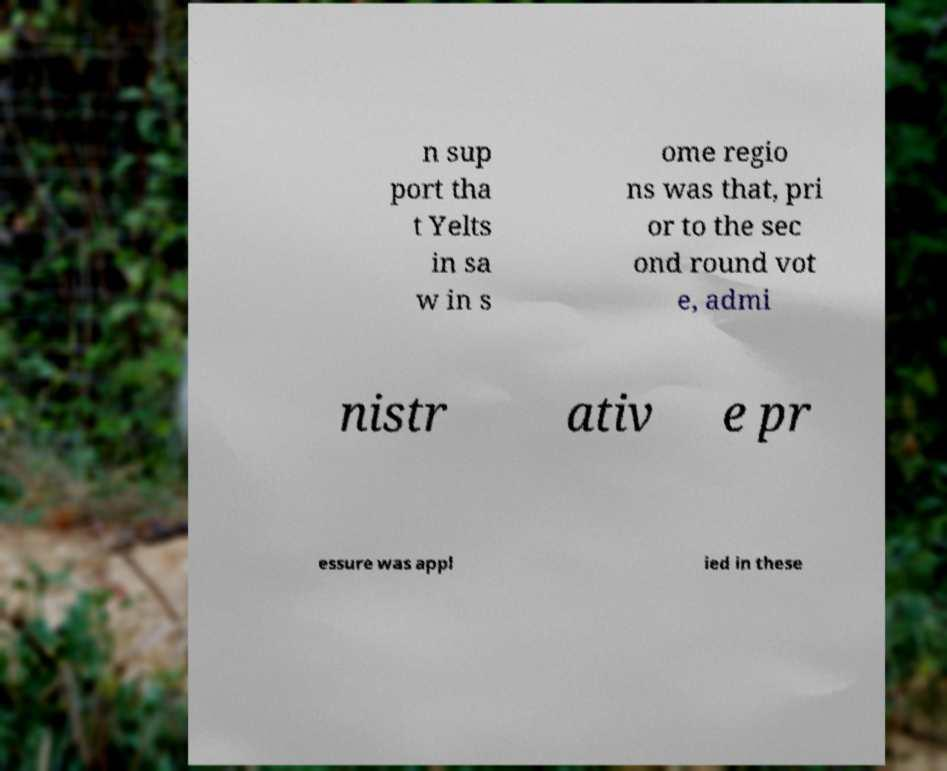There's text embedded in this image that I need extracted. Can you transcribe it verbatim? n sup port tha t Yelts in sa w in s ome regio ns was that, pri or to the sec ond round vot e, admi nistr ativ e pr essure was appl ied in these 